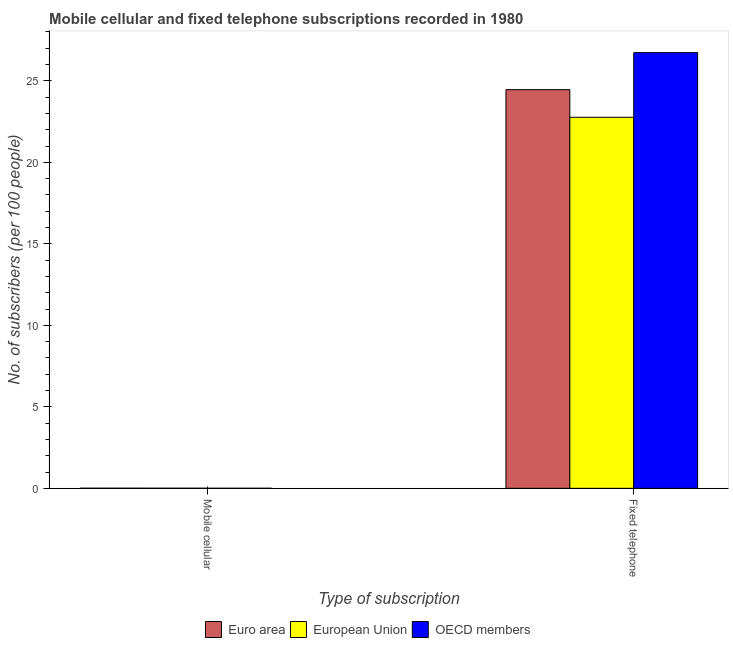Are the number of bars per tick equal to the number of legend labels?
Keep it short and to the point. Yes. How many bars are there on the 2nd tick from the right?
Ensure brevity in your answer.  3. What is the label of the 1st group of bars from the left?
Provide a succinct answer. Mobile cellular. What is the number of fixed telephone subscribers in OECD members?
Your answer should be very brief. 26.73. Across all countries, what is the maximum number of mobile cellular subscribers?
Your answer should be compact. 0.01. Across all countries, what is the minimum number of mobile cellular subscribers?
Provide a short and direct response. 0. What is the total number of mobile cellular subscribers in the graph?
Make the answer very short. 0.02. What is the difference between the number of mobile cellular subscribers in European Union and that in OECD members?
Give a very brief answer. 0. What is the difference between the number of mobile cellular subscribers in European Union and the number of fixed telephone subscribers in Euro area?
Ensure brevity in your answer.  -24.45. What is the average number of mobile cellular subscribers per country?
Keep it short and to the point. 0.01. What is the difference between the number of mobile cellular subscribers and number of fixed telephone subscribers in OECD members?
Your answer should be compact. -26.73. What is the ratio of the number of mobile cellular subscribers in European Union to that in OECD members?
Ensure brevity in your answer.  2.12. Is the number of mobile cellular subscribers in European Union less than that in Euro area?
Your answer should be compact. Yes. What does the 1st bar from the left in Mobile cellular represents?
Make the answer very short. Euro area. How many bars are there?
Your response must be concise. 6. How many countries are there in the graph?
Ensure brevity in your answer.  3. What is the difference between two consecutive major ticks on the Y-axis?
Offer a very short reply. 5. Does the graph contain any zero values?
Your answer should be compact. No. Where does the legend appear in the graph?
Give a very brief answer. Bottom center. How many legend labels are there?
Your answer should be very brief. 3. What is the title of the graph?
Provide a short and direct response. Mobile cellular and fixed telephone subscriptions recorded in 1980. Does "Somalia" appear as one of the legend labels in the graph?
Your answer should be compact. No. What is the label or title of the X-axis?
Ensure brevity in your answer.  Type of subscription. What is the label or title of the Y-axis?
Your answer should be very brief. No. of subscribers (per 100 people). What is the No. of subscribers (per 100 people) in Euro area in Mobile cellular?
Give a very brief answer. 0.01. What is the No. of subscribers (per 100 people) of European Union in Mobile cellular?
Offer a terse response. 0.01. What is the No. of subscribers (per 100 people) in OECD members in Mobile cellular?
Provide a short and direct response. 0. What is the No. of subscribers (per 100 people) in Euro area in Fixed telephone?
Your response must be concise. 24.46. What is the No. of subscribers (per 100 people) of European Union in Fixed telephone?
Keep it short and to the point. 22.77. What is the No. of subscribers (per 100 people) in OECD members in Fixed telephone?
Your answer should be compact. 26.73. Across all Type of subscription, what is the maximum No. of subscribers (per 100 people) of Euro area?
Keep it short and to the point. 24.46. Across all Type of subscription, what is the maximum No. of subscribers (per 100 people) of European Union?
Offer a terse response. 22.77. Across all Type of subscription, what is the maximum No. of subscribers (per 100 people) of OECD members?
Offer a terse response. 26.73. Across all Type of subscription, what is the minimum No. of subscribers (per 100 people) in Euro area?
Your response must be concise. 0.01. Across all Type of subscription, what is the minimum No. of subscribers (per 100 people) in European Union?
Your response must be concise. 0.01. Across all Type of subscription, what is the minimum No. of subscribers (per 100 people) of OECD members?
Offer a very short reply. 0. What is the total No. of subscribers (per 100 people) of Euro area in the graph?
Provide a succinct answer. 24.47. What is the total No. of subscribers (per 100 people) in European Union in the graph?
Give a very brief answer. 22.77. What is the total No. of subscribers (per 100 people) of OECD members in the graph?
Your response must be concise. 26.74. What is the difference between the No. of subscribers (per 100 people) of Euro area in Mobile cellular and that in Fixed telephone?
Provide a short and direct response. -24.45. What is the difference between the No. of subscribers (per 100 people) of European Union in Mobile cellular and that in Fixed telephone?
Your answer should be very brief. -22.76. What is the difference between the No. of subscribers (per 100 people) of OECD members in Mobile cellular and that in Fixed telephone?
Keep it short and to the point. -26.73. What is the difference between the No. of subscribers (per 100 people) of Euro area in Mobile cellular and the No. of subscribers (per 100 people) of European Union in Fixed telephone?
Provide a succinct answer. -22.76. What is the difference between the No. of subscribers (per 100 people) of Euro area in Mobile cellular and the No. of subscribers (per 100 people) of OECD members in Fixed telephone?
Provide a short and direct response. -26.73. What is the difference between the No. of subscribers (per 100 people) in European Union in Mobile cellular and the No. of subscribers (per 100 people) in OECD members in Fixed telephone?
Your answer should be compact. -26.73. What is the average No. of subscribers (per 100 people) in Euro area per Type of subscription?
Offer a very short reply. 12.23. What is the average No. of subscribers (per 100 people) of European Union per Type of subscription?
Make the answer very short. 11.39. What is the average No. of subscribers (per 100 people) of OECD members per Type of subscription?
Offer a very short reply. 13.37. What is the difference between the No. of subscribers (per 100 people) in Euro area and No. of subscribers (per 100 people) in European Union in Mobile cellular?
Offer a very short reply. 0. What is the difference between the No. of subscribers (per 100 people) of Euro area and No. of subscribers (per 100 people) of OECD members in Mobile cellular?
Provide a short and direct response. 0.01. What is the difference between the No. of subscribers (per 100 people) of European Union and No. of subscribers (per 100 people) of OECD members in Mobile cellular?
Your answer should be very brief. 0. What is the difference between the No. of subscribers (per 100 people) of Euro area and No. of subscribers (per 100 people) of European Union in Fixed telephone?
Provide a short and direct response. 1.69. What is the difference between the No. of subscribers (per 100 people) in Euro area and No. of subscribers (per 100 people) in OECD members in Fixed telephone?
Your answer should be compact. -2.27. What is the difference between the No. of subscribers (per 100 people) in European Union and No. of subscribers (per 100 people) in OECD members in Fixed telephone?
Your answer should be compact. -3.97. What is the ratio of the No. of subscribers (per 100 people) of European Union in Mobile cellular to that in Fixed telephone?
Make the answer very short. 0. What is the difference between the highest and the second highest No. of subscribers (per 100 people) in Euro area?
Ensure brevity in your answer.  24.45. What is the difference between the highest and the second highest No. of subscribers (per 100 people) of European Union?
Offer a very short reply. 22.76. What is the difference between the highest and the second highest No. of subscribers (per 100 people) in OECD members?
Ensure brevity in your answer.  26.73. What is the difference between the highest and the lowest No. of subscribers (per 100 people) in Euro area?
Make the answer very short. 24.45. What is the difference between the highest and the lowest No. of subscribers (per 100 people) of European Union?
Provide a succinct answer. 22.76. What is the difference between the highest and the lowest No. of subscribers (per 100 people) in OECD members?
Keep it short and to the point. 26.73. 